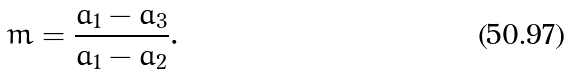Convert formula to latex. <formula><loc_0><loc_0><loc_500><loc_500>m = \frac { a _ { 1 } - a _ { 3 } } { a _ { 1 } - a _ { 2 } } .</formula> 